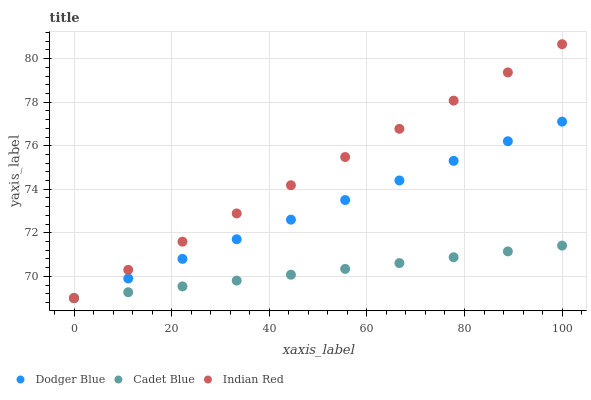Does Cadet Blue have the minimum area under the curve?
Answer yes or no. Yes. Does Indian Red have the maximum area under the curve?
Answer yes or no. Yes. Does Dodger Blue have the minimum area under the curve?
Answer yes or no. No. Does Dodger Blue have the maximum area under the curve?
Answer yes or no. No. Is Dodger Blue the smoothest?
Answer yes or no. Yes. Is Cadet Blue the roughest?
Answer yes or no. Yes. Is Indian Red the smoothest?
Answer yes or no. No. Is Indian Red the roughest?
Answer yes or no. No. Does Cadet Blue have the lowest value?
Answer yes or no. Yes. Does Indian Red have the highest value?
Answer yes or no. Yes. Does Dodger Blue have the highest value?
Answer yes or no. No. Does Cadet Blue intersect Indian Red?
Answer yes or no. Yes. Is Cadet Blue less than Indian Red?
Answer yes or no. No. Is Cadet Blue greater than Indian Red?
Answer yes or no. No. 